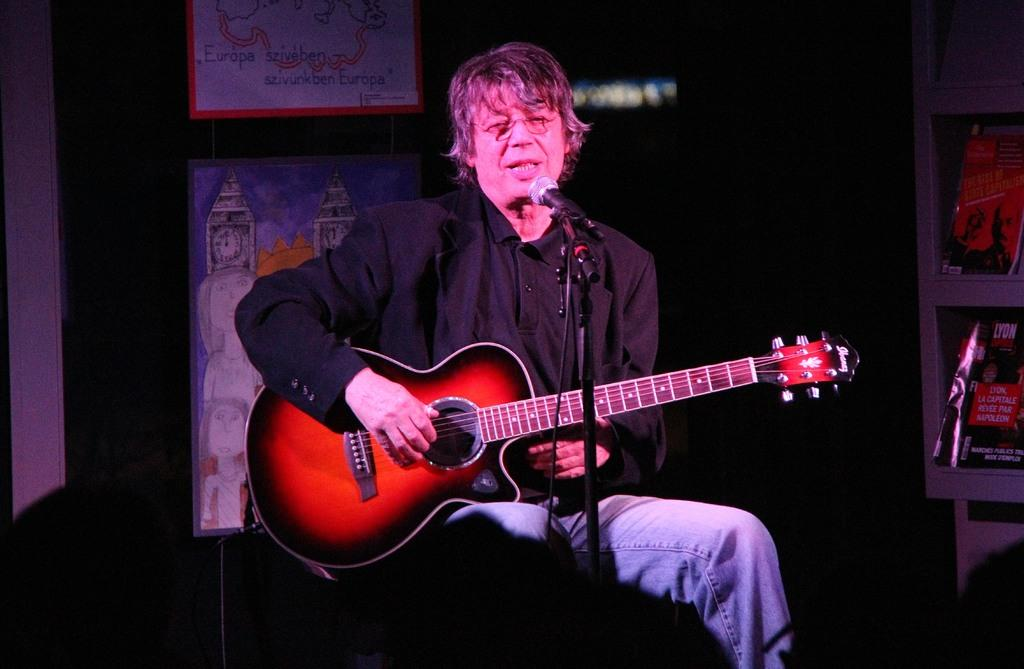Who is the person in the image? There is a man in the image. What is the man wearing? The man is wearing a black coat. What is the man doing in the image? The man is sitting on a table and playing a guitar. What can be seen in the background of the image? There is a painted chart and posters visible in the background. How much money is the man holding in the image? The man is not holding any money in the image; he is playing a guitar while sitting on a table. Is there a rat visible in the image? No, there is no rat present in the image. 